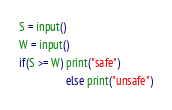Convert code to text. <code><loc_0><loc_0><loc_500><loc_500><_Python_>S = input()
W = input()
if(S >= W) print("safe")
                 else print("unsafe")
</code> 